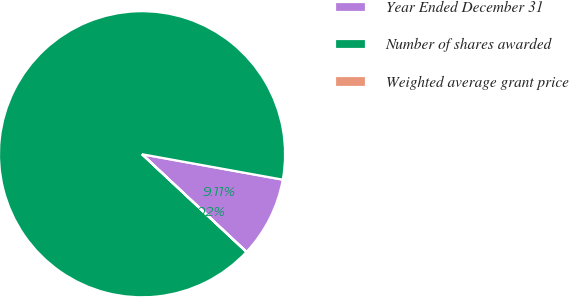<chart> <loc_0><loc_0><loc_500><loc_500><pie_chart><fcel>Year Ended December 31<fcel>Number of shares awarded<fcel>Weighted average grant price<nl><fcel>9.11%<fcel>90.87%<fcel>0.02%<nl></chart> 